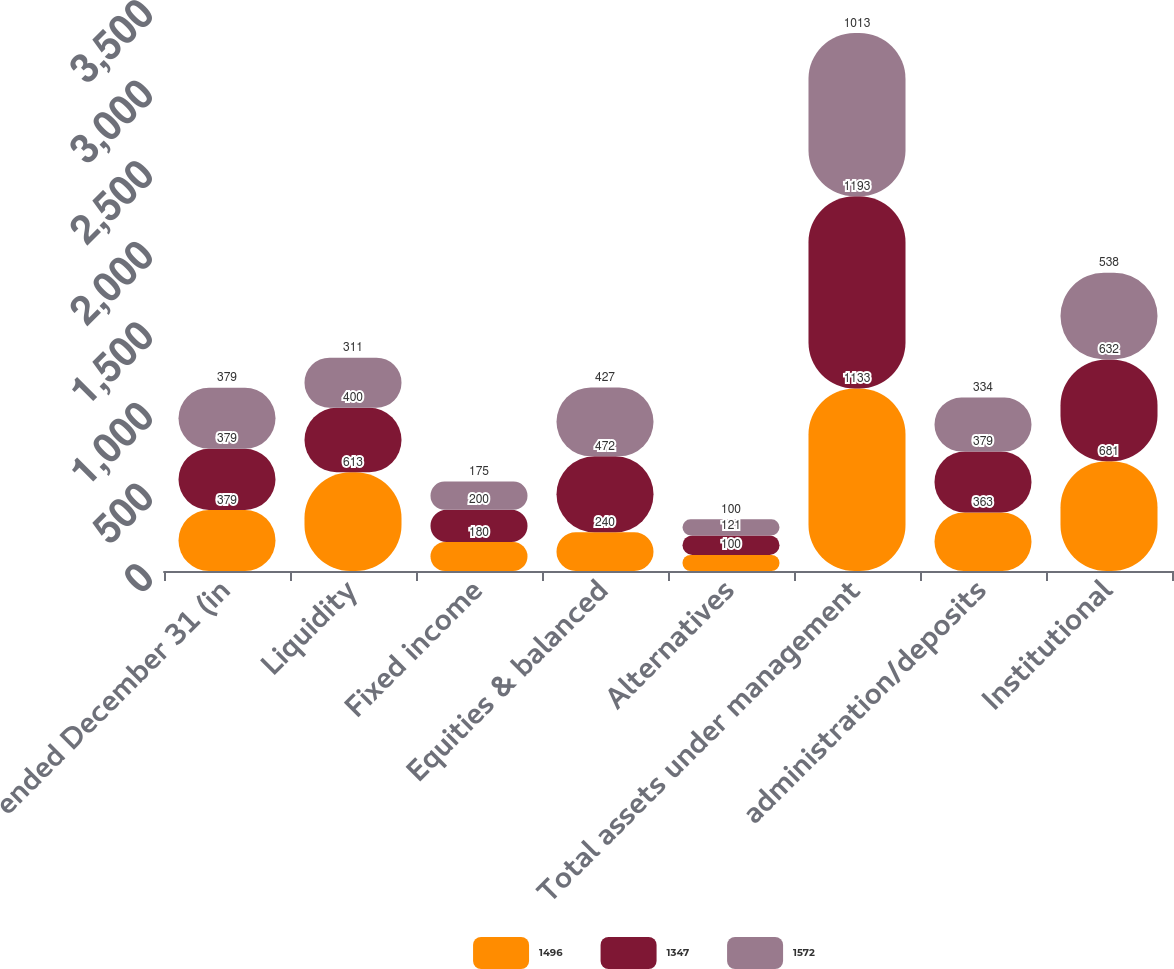Convert chart. <chart><loc_0><loc_0><loc_500><loc_500><stacked_bar_chart><ecel><fcel>ended December 31 (in<fcel>Liquidity<fcel>Fixed income<fcel>Equities & balanced<fcel>Alternatives<fcel>Total assets under management<fcel>administration/deposits<fcel>Institutional<nl><fcel>1496<fcel>379<fcel>613<fcel>180<fcel>240<fcel>100<fcel>1133<fcel>363<fcel>681<nl><fcel>1347<fcel>379<fcel>400<fcel>200<fcel>472<fcel>121<fcel>1193<fcel>379<fcel>632<nl><fcel>1572<fcel>379<fcel>311<fcel>175<fcel>427<fcel>100<fcel>1013<fcel>334<fcel>538<nl></chart> 